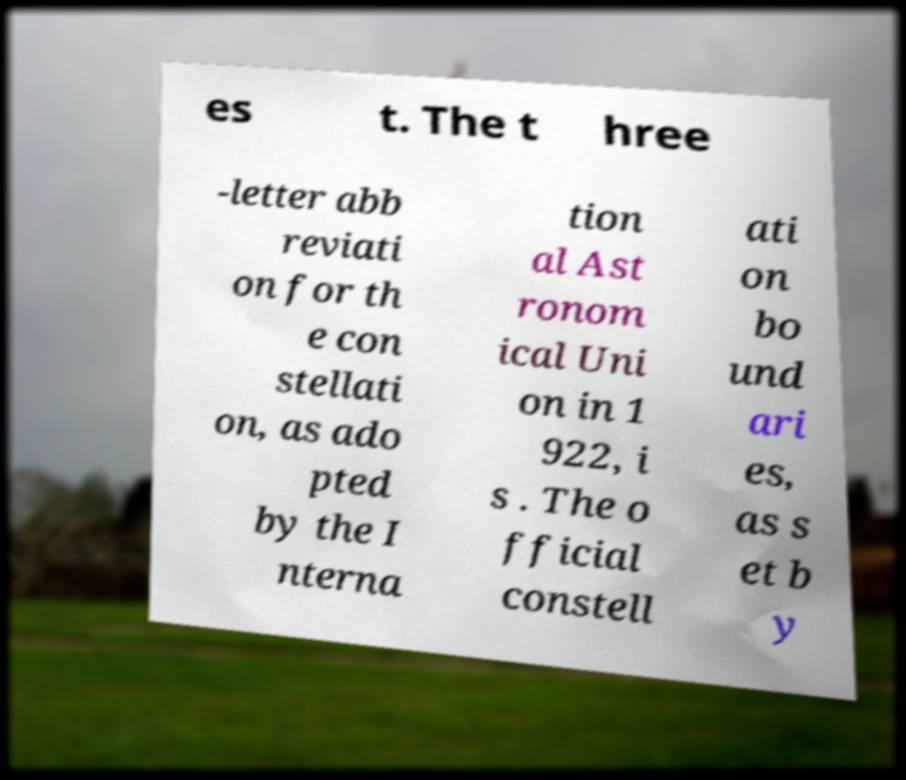Please identify and transcribe the text found in this image. es t. The t hree -letter abb reviati on for th e con stellati on, as ado pted by the I nterna tion al Ast ronom ical Uni on in 1 922, i s . The o fficial constell ati on bo und ari es, as s et b y 